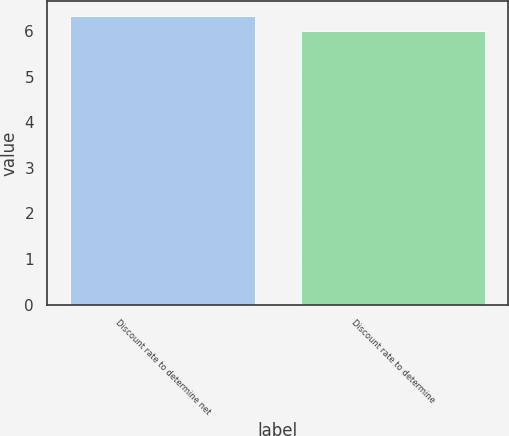<chart> <loc_0><loc_0><loc_500><loc_500><bar_chart><fcel>Discount rate to determine net<fcel>Discount rate to determine<nl><fcel>6.33<fcel>6<nl></chart> 